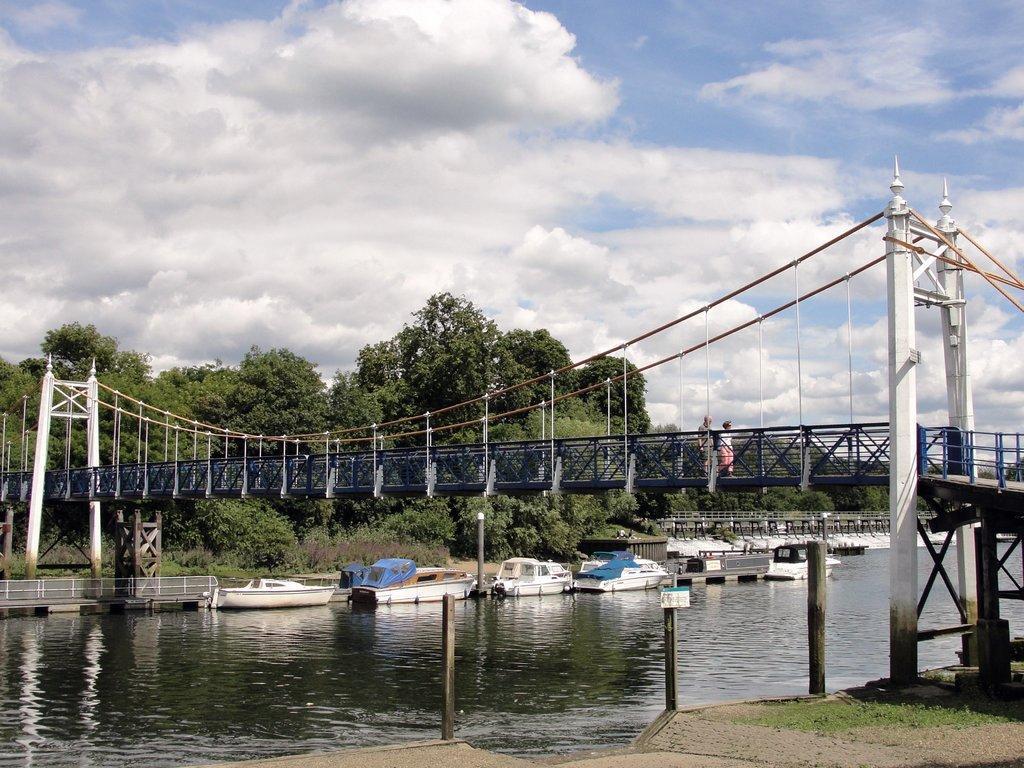Can you describe this image briefly? In this image we can see a bridge and on the bridge we can see two persons. At the bottom we can see water and on the water we can see few boats. Behind the boats there are few trees. At the top we can see the sky. On the right side, we can see the pillars and the grass. 